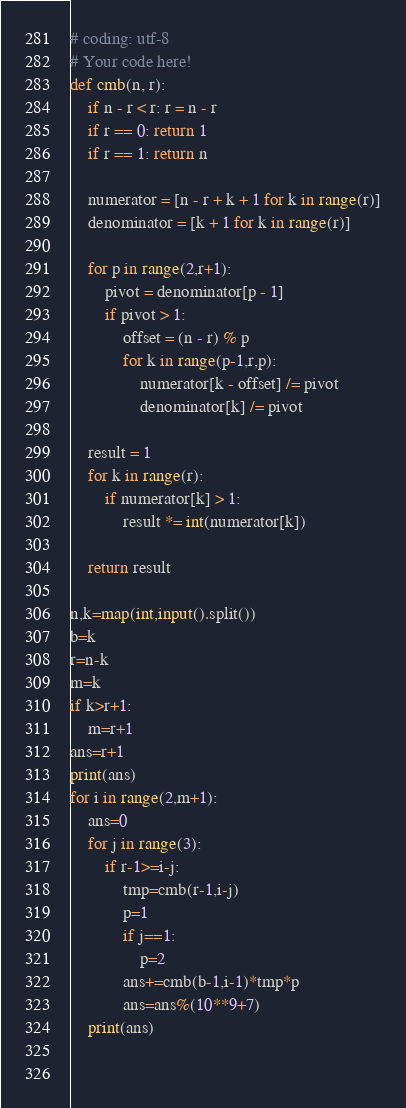Convert code to text. <code><loc_0><loc_0><loc_500><loc_500><_Python_># coding: utf-8
# Your code here!
def cmb(n, r):
    if n - r < r: r = n - r
    if r == 0: return 1
    if r == 1: return n

    numerator = [n - r + k + 1 for k in range(r)]
    denominator = [k + 1 for k in range(r)]

    for p in range(2,r+1):
        pivot = denominator[p - 1]
        if pivot > 1:
            offset = (n - r) % p
            for k in range(p-1,r,p):
                numerator[k - offset] /= pivot
                denominator[k] /= pivot

    result = 1
    for k in range(r):
        if numerator[k] > 1:
            result *= int(numerator[k])

    return result

n,k=map(int,input().split())
b=k
r=n-k
m=k
if k>r+1:
    m=r+1
ans=r+1
print(ans)
for i in range(2,m+1):
    ans=0
    for j in range(3):
        if r-1>=i-j:
            tmp=cmb(r-1,i-j)
            p=1
            if j==1:
                p=2
            ans+=cmb(b-1,i-1)*tmp*p
            ans=ans%(10**9+7)
    print(ans)

        
</code> 